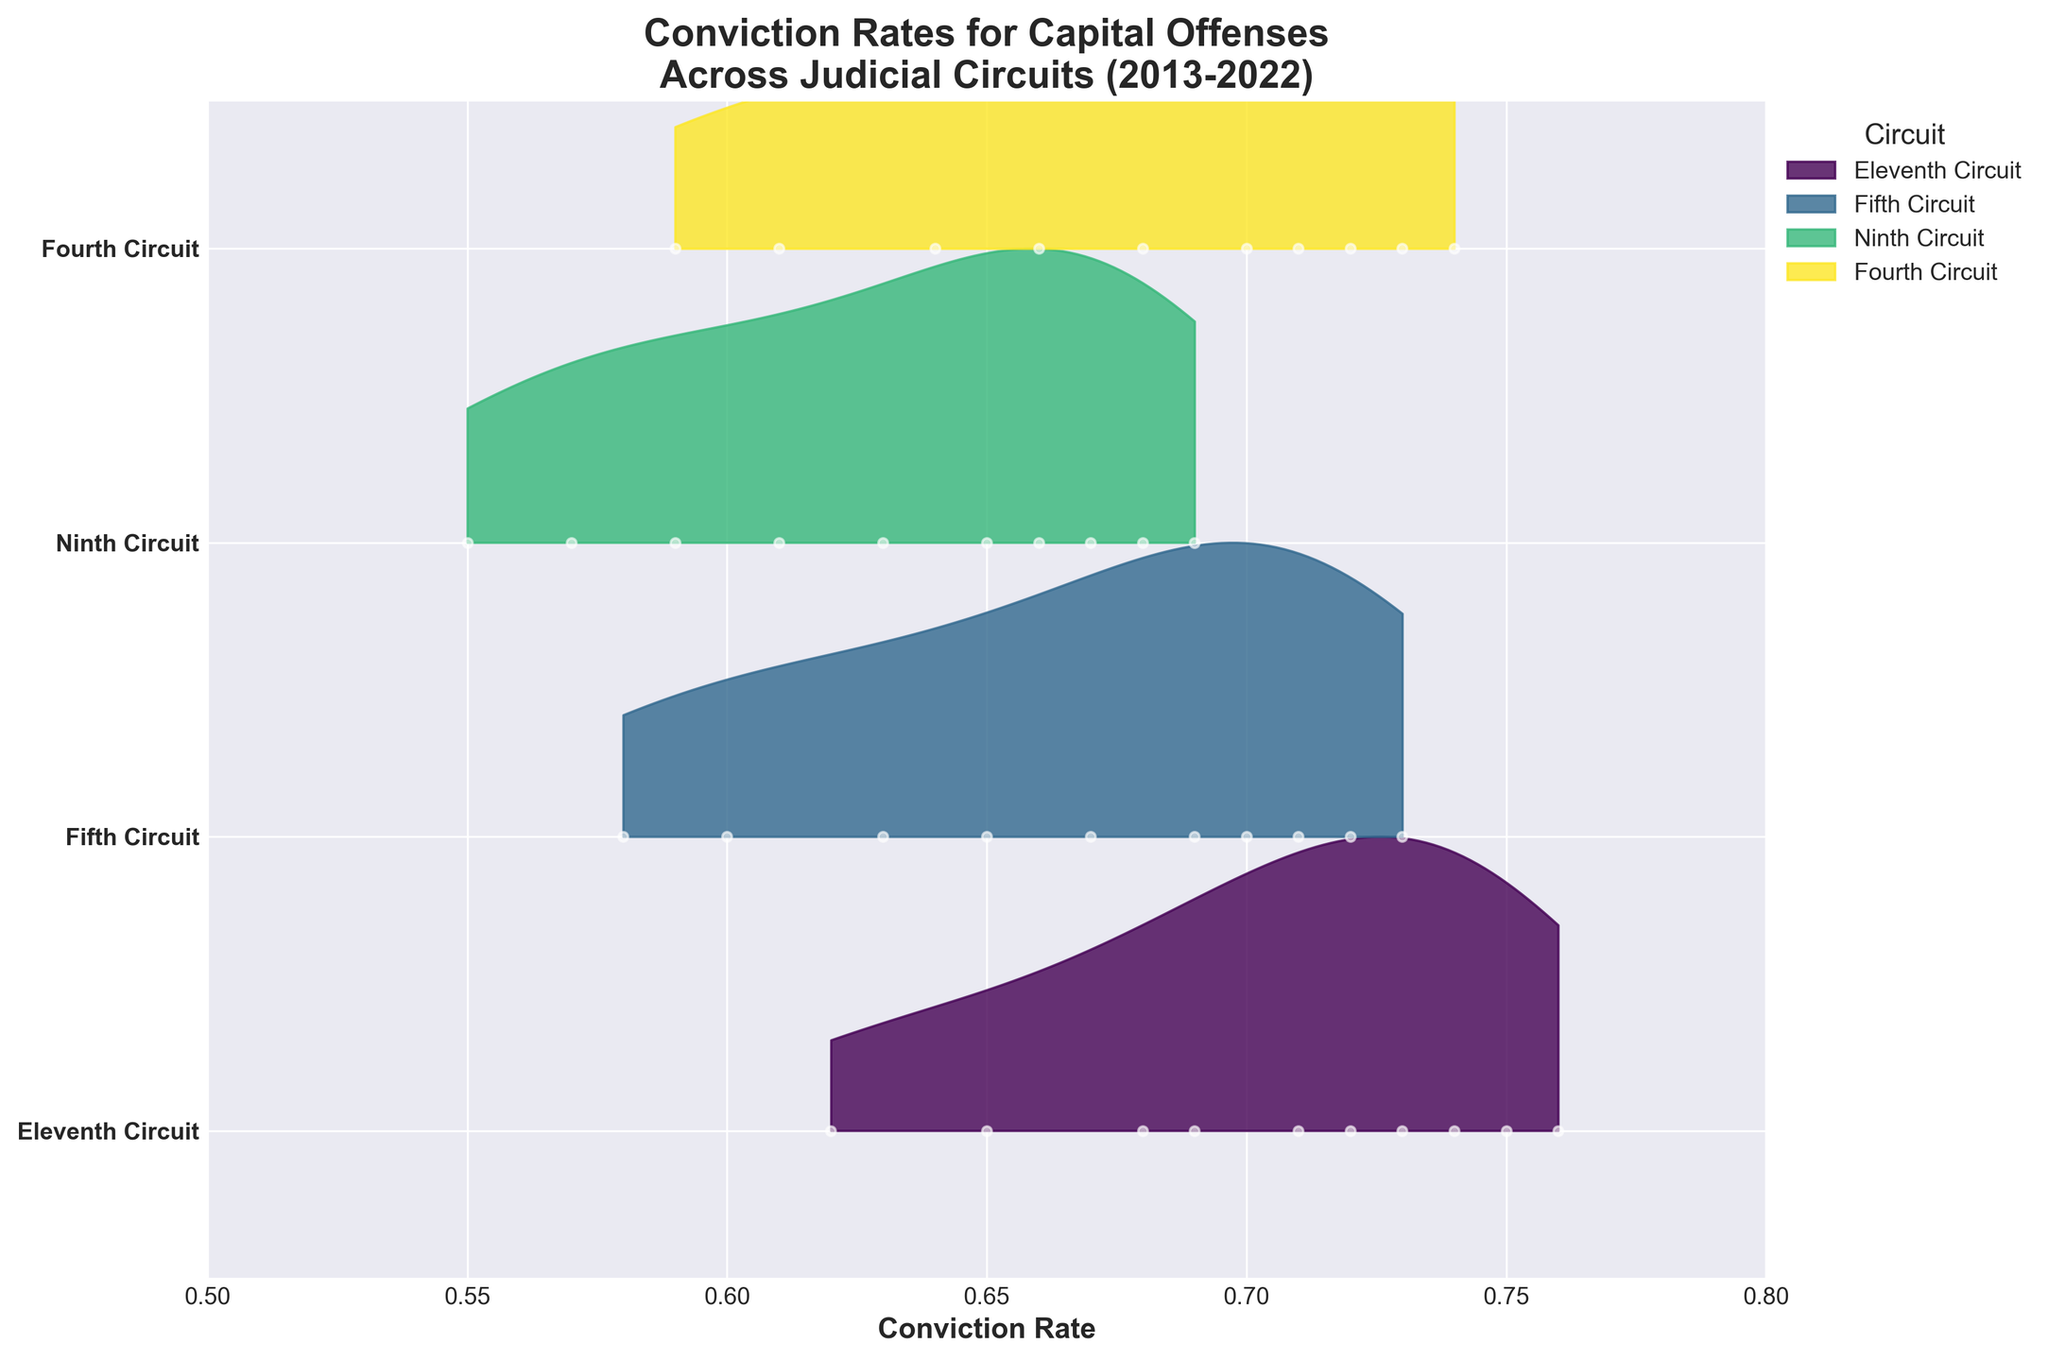How many judicial circuits are represented in the plot? There are labels on the y-axis representing the different judicial circuits included in the plot. Counting them gives four unique circuits.
Answer: Four Which judicial circuit has the highest conviction rate in 2022? The rightmost part of each ridgeline corresponds to the year 2022. The highest conviction rate belongs to the Eleventh Circuit, which reaches approximately 0.76.
Answer: Eleventh Circuit Was there any year where the Ninth Circuit had a sudden drop in conviction rates? The plot shows the trend of conviction rates over the years. The Ninth Circuit has a slightly lower rate in 2020 (around 0.66) compared to the adjacent years 2019 (0.67) and 2021 (0.68), but no significant drop.
Answer: No Which two circuits had the closest conviction rates in 2017, and what were their rates? The year 2017 can be located consistently along the y-axis overlap for each circuit. The Fourth Circuit and the Fifth Circuit have rates of 0.68 and 0.67 respectively, which are very close.
Answer: Fourth Circuit: 0.68, Fifth Circuit: 0.67 Has the Eleventh Circuit shown a consistent upward trend in conviction rates over the past decade? Observing the Eleventh Circuit's ridgeline from left (2013) to right (2022), it shows a mostly steady increase from 0.62 to 0.76, indicating a generally upward trend.
Answer: Yes What is the average conviction rate for the Fourth Circuit over the past decade? Summing the Fourth Circuit rates and dividing by the number of years: (0.59 + 0.61 + 0.64 + 0.66 + 0.68 + 0.70 + 0.72 + 0.71 + 0.73 + 0.74)/10 = 6.98/10 = 0.698
Answer: 0.698 Which circuit has shown the least variability in conviction rates over the years? The density of the ridgelines indicates variability. The Fifth Circuit has relatively tightly clustered conviction rates compared to other circuits, indicating the least variability.
Answer: Fifth Circuit By how much did the conviction rate for the Eleventh Circuit increase from 2013 to 2022? The Eleventh Circuit’s rate in 2013 was 0.62 and in 2022 it was 0.76. The increase is 0.76 - 0.62 = 0.14.
Answer: 0.14 Is there any year where all the circuits had almost the same conviction rates? Examining the plot, the year 2014 shows the closest convergence, with rates approximately between 0.57 and 0.65 for all circuits, indicating a similar range.
Answer: 2014 